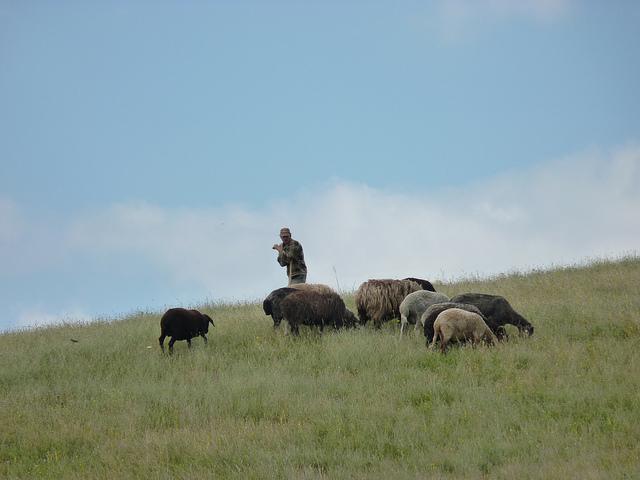How many sheep are in the photo?
Give a very brief answer. 2. 